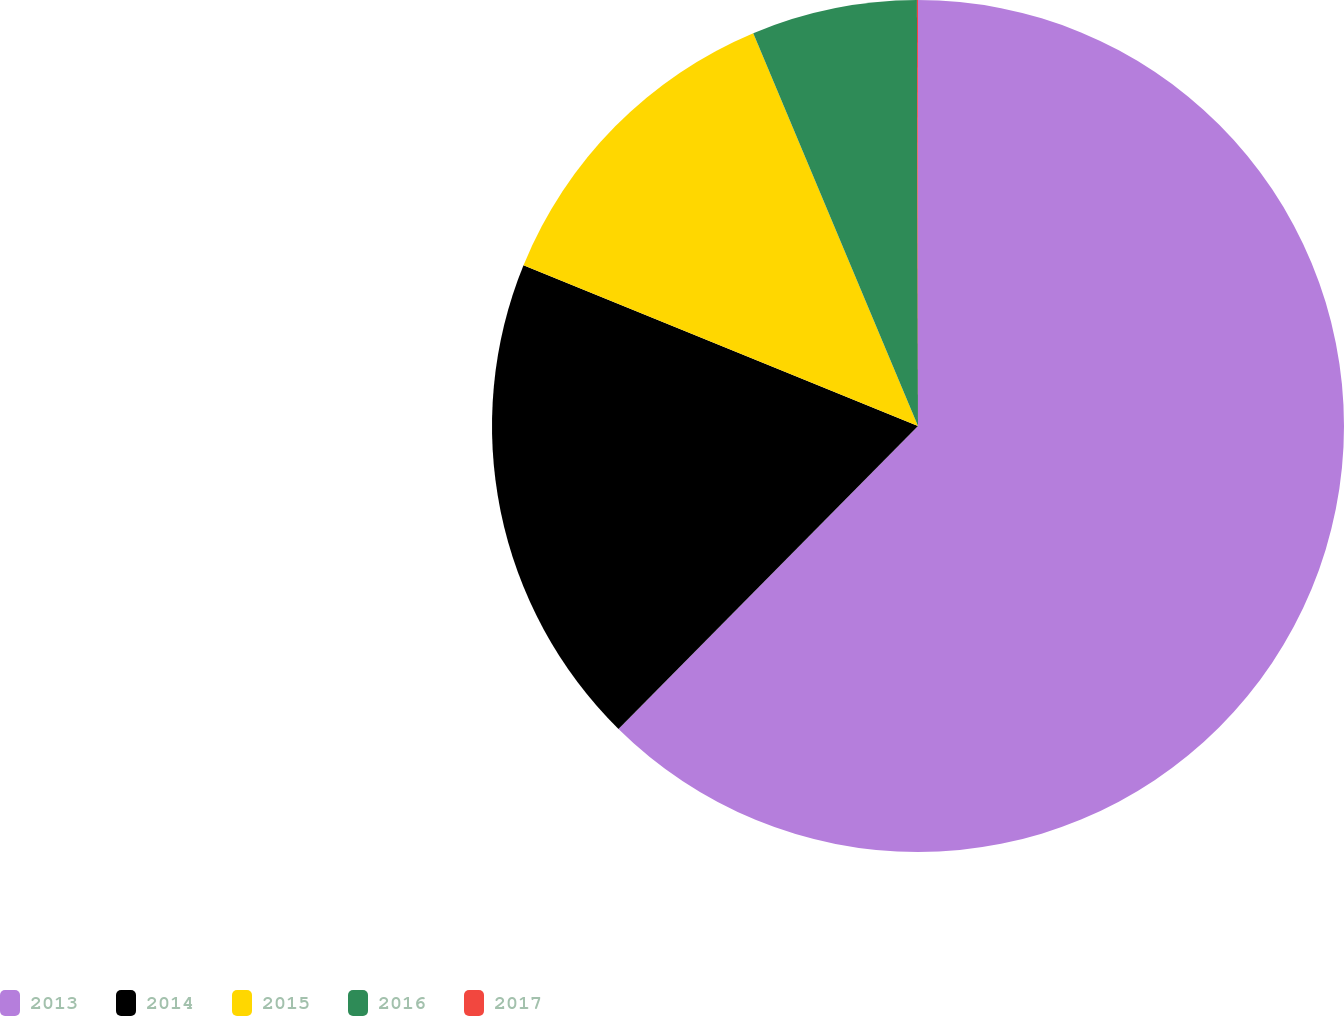Convert chart to OTSL. <chart><loc_0><loc_0><loc_500><loc_500><pie_chart><fcel>2013<fcel>2014<fcel>2015<fcel>2016<fcel>2017<nl><fcel>62.41%<fcel>18.75%<fcel>12.52%<fcel>6.28%<fcel>0.04%<nl></chart> 